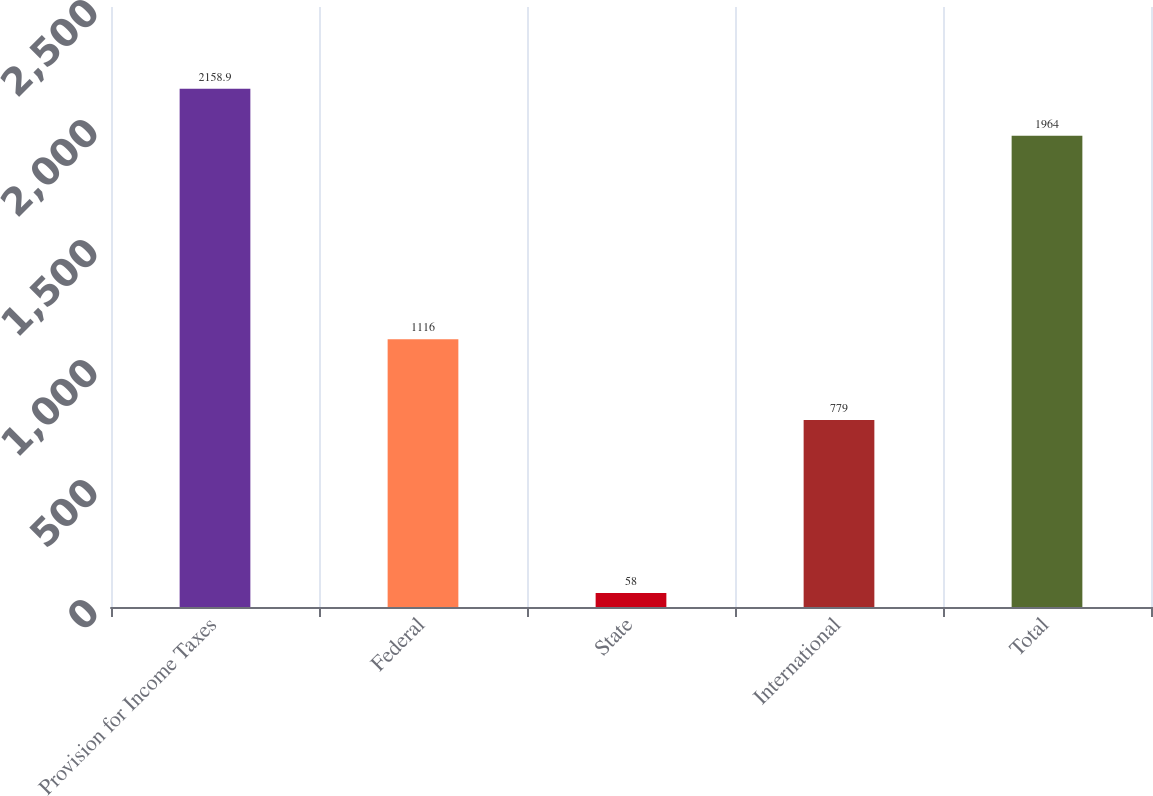<chart> <loc_0><loc_0><loc_500><loc_500><bar_chart><fcel>Provision for Income Taxes<fcel>Federal<fcel>State<fcel>International<fcel>Total<nl><fcel>2158.9<fcel>1116<fcel>58<fcel>779<fcel>1964<nl></chart> 